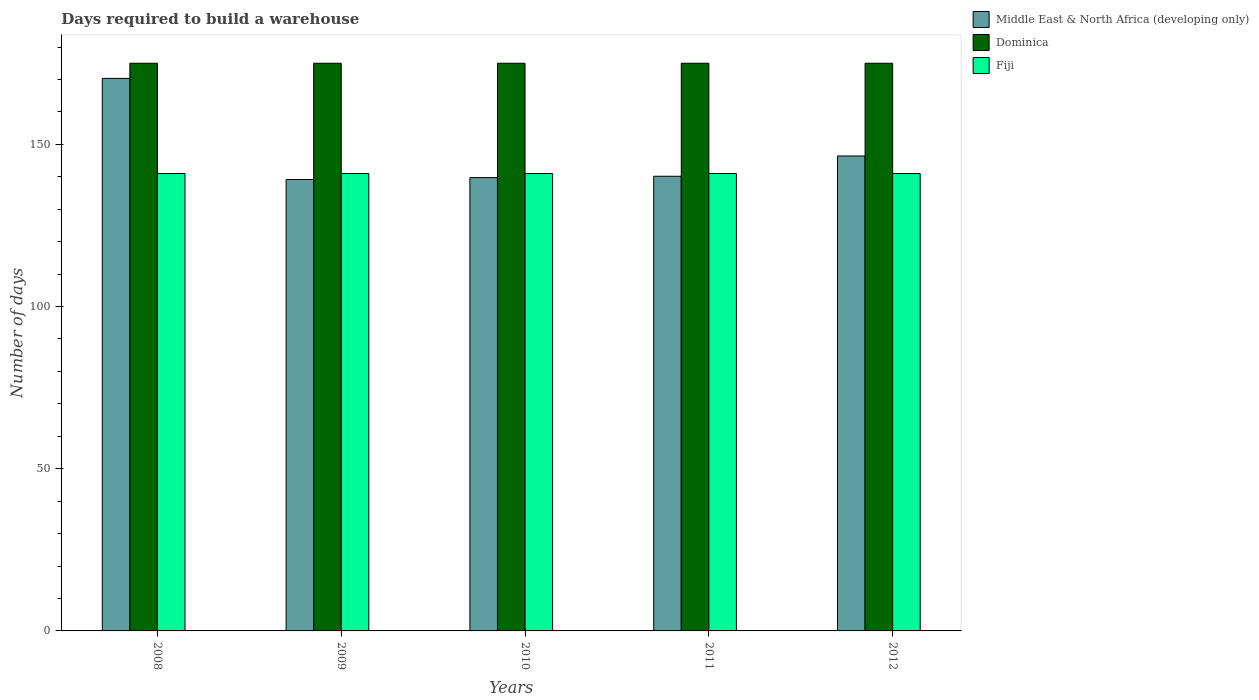How many different coloured bars are there?
Provide a short and direct response. 3. How many groups of bars are there?
Your response must be concise. 5. Are the number of bars per tick equal to the number of legend labels?
Provide a succinct answer. Yes. What is the days required to build a warehouse in in Dominica in 2011?
Give a very brief answer. 175. Across all years, what is the maximum days required to build a warehouse in in Middle East & North Africa (developing only)?
Your answer should be very brief. 170.33. Across all years, what is the minimum days required to build a warehouse in in Middle East & North Africa (developing only)?
Give a very brief answer. 139.17. What is the total days required to build a warehouse in in Fiji in the graph?
Keep it short and to the point. 705. What is the difference between the days required to build a warehouse in in Dominica in 2011 and that in 2012?
Keep it short and to the point. 0. What is the difference between the days required to build a warehouse in in Middle East & North Africa (developing only) in 2010 and the days required to build a warehouse in in Dominica in 2009?
Your response must be concise. -35.25. What is the average days required to build a warehouse in in Middle East & North Africa (developing only) per year?
Provide a short and direct response. 147.17. In the year 2009, what is the difference between the days required to build a warehouse in in Middle East & North Africa (developing only) and days required to build a warehouse in in Fiji?
Ensure brevity in your answer.  -1.83. In how many years, is the days required to build a warehouse in in Dominica greater than 140 days?
Your answer should be very brief. 5. Is the days required to build a warehouse in in Dominica in 2008 less than that in 2010?
Offer a very short reply. No. What is the difference between the highest and the second highest days required to build a warehouse in in Dominica?
Give a very brief answer. 0. What is the difference between the highest and the lowest days required to build a warehouse in in Dominica?
Your response must be concise. 0. In how many years, is the days required to build a warehouse in in Middle East & North Africa (developing only) greater than the average days required to build a warehouse in in Middle East & North Africa (developing only) taken over all years?
Provide a succinct answer. 1. Is the sum of the days required to build a warehouse in in Middle East & North Africa (developing only) in 2010 and 2012 greater than the maximum days required to build a warehouse in in Dominica across all years?
Give a very brief answer. Yes. What does the 1st bar from the left in 2009 represents?
Your response must be concise. Middle East & North Africa (developing only). What does the 3rd bar from the right in 2009 represents?
Offer a terse response. Middle East & North Africa (developing only). Are all the bars in the graph horizontal?
Provide a succinct answer. No. How many years are there in the graph?
Your answer should be very brief. 5. Does the graph contain any zero values?
Offer a very short reply. No. Does the graph contain grids?
Provide a succinct answer. No. Where does the legend appear in the graph?
Make the answer very short. Top right. How many legend labels are there?
Give a very brief answer. 3. What is the title of the graph?
Offer a very short reply. Days required to build a warehouse. Does "Belize" appear as one of the legend labels in the graph?
Provide a succinct answer. No. What is the label or title of the Y-axis?
Provide a succinct answer. Number of days. What is the Number of days of Middle East & North Africa (developing only) in 2008?
Offer a very short reply. 170.33. What is the Number of days in Dominica in 2008?
Offer a very short reply. 175. What is the Number of days in Fiji in 2008?
Offer a terse response. 141. What is the Number of days in Middle East & North Africa (developing only) in 2009?
Keep it short and to the point. 139.17. What is the Number of days of Dominica in 2009?
Keep it short and to the point. 175. What is the Number of days of Fiji in 2009?
Make the answer very short. 141. What is the Number of days of Middle East & North Africa (developing only) in 2010?
Your response must be concise. 139.75. What is the Number of days of Dominica in 2010?
Offer a very short reply. 175. What is the Number of days in Fiji in 2010?
Provide a succinct answer. 141. What is the Number of days in Middle East & North Africa (developing only) in 2011?
Keep it short and to the point. 140.17. What is the Number of days in Dominica in 2011?
Give a very brief answer. 175. What is the Number of days in Fiji in 2011?
Keep it short and to the point. 141. What is the Number of days in Middle East & North Africa (developing only) in 2012?
Your answer should be very brief. 146.42. What is the Number of days of Dominica in 2012?
Ensure brevity in your answer.  175. What is the Number of days in Fiji in 2012?
Your answer should be compact. 141. Across all years, what is the maximum Number of days of Middle East & North Africa (developing only)?
Keep it short and to the point. 170.33. Across all years, what is the maximum Number of days of Dominica?
Your response must be concise. 175. Across all years, what is the maximum Number of days of Fiji?
Offer a very short reply. 141. Across all years, what is the minimum Number of days of Middle East & North Africa (developing only)?
Make the answer very short. 139.17. Across all years, what is the minimum Number of days of Dominica?
Offer a terse response. 175. Across all years, what is the minimum Number of days in Fiji?
Your answer should be compact. 141. What is the total Number of days in Middle East & North Africa (developing only) in the graph?
Your response must be concise. 735.83. What is the total Number of days in Dominica in the graph?
Give a very brief answer. 875. What is the total Number of days in Fiji in the graph?
Your answer should be compact. 705. What is the difference between the Number of days in Middle East & North Africa (developing only) in 2008 and that in 2009?
Keep it short and to the point. 31.17. What is the difference between the Number of days in Middle East & North Africa (developing only) in 2008 and that in 2010?
Provide a short and direct response. 30.58. What is the difference between the Number of days in Middle East & North Africa (developing only) in 2008 and that in 2011?
Provide a short and direct response. 30.17. What is the difference between the Number of days of Dominica in 2008 and that in 2011?
Give a very brief answer. 0. What is the difference between the Number of days in Fiji in 2008 and that in 2011?
Your response must be concise. 0. What is the difference between the Number of days of Middle East & North Africa (developing only) in 2008 and that in 2012?
Offer a very short reply. 23.92. What is the difference between the Number of days in Dominica in 2008 and that in 2012?
Ensure brevity in your answer.  0. What is the difference between the Number of days of Middle East & North Africa (developing only) in 2009 and that in 2010?
Offer a very short reply. -0.58. What is the difference between the Number of days in Dominica in 2009 and that in 2010?
Make the answer very short. 0. What is the difference between the Number of days in Fiji in 2009 and that in 2010?
Your answer should be very brief. 0. What is the difference between the Number of days of Fiji in 2009 and that in 2011?
Make the answer very short. 0. What is the difference between the Number of days of Middle East & North Africa (developing only) in 2009 and that in 2012?
Provide a succinct answer. -7.25. What is the difference between the Number of days in Fiji in 2009 and that in 2012?
Your answer should be compact. 0. What is the difference between the Number of days of Middle East & North Africa (developing only) in 2010 and that in 2011?
Keep it short and to the point. -0.42. What is the difference between the Number of days in Middle East & North Africa (developing only) in 2010 and that in 2012?
Provide a short and direct response. -6.67. What is the difference between the Number of days in Fiji in 2010 and that in 2012?
Your answer should be very brief. 0. What is the difference between the Number of days in Middle East & North Africa (developing only) in 2011 and that in 2012?
Give a very brief answer. -6.25. What is the difference between the Number of days in Dominica in 2011 and that in 2012?
Ensure brevity in your answer.  0. What is the difference between the Number of days in Middle East & North Africa (developing only) in 2008 and the Number of days in Dominica in 2009?
Give a very brief answer. -4.67. What is the difference between the Number of days in Middle East & North Africa (developing only) in 2008 and the Number of days in Fiji in 2009?
Give a very brief answer. 29.33. What is the difference between the Number of days in Dominica in 2008 and the Number of days in Fiji in 2009?
Provide a short and direct response. 34. What is the difference between the Number of days of Middle East & North Africa (developing only) in 2008 and the Number of days of Dominica in 2010?
Your answer should be compact. -4.67. What is the difference between the Number of days of Middle East & North Africa (developing only) in 2008 and the Number of days of Fiji in 2010?
Offer a terse response. 29.33. What is the difference between the Number of days in Dominica in 2008 and the Number of days in Fiji in 2010?
Offer a terse response. 34. What is the difference between the Number of days of Middle East & North Africa (developing only) in 2008 and the Number of days of Dominica in 2011?
Offer a terse response. -4.67. What is the difference between the Number of days of Middle East & North Africa (developing only) in 2008 and the Number of days of Fiji in 2011?
Make the answer very short. 29.33. What is the difference between the Number of days in Middle East & North Africa (developing only) in 2008 and the Number of days in Dominica in 2012?
Make the answer very short. -4.67. What is the difference between the Number of days in Middle East & North Africa (developing only) in 2008 and the Number of days in Fiji in 2012?
Your answer should be very brief. 29.33. What is the difference between the Number of days in Dominica in 2008 and the Number of days in Fiji in 2012?
Keep it short and to the point. 34. What is the difference between the Number of days in Middle East & North Africa (developing only) in 2009 and the Number of days in Dominica in 2010?
Ensure brevity in your answer.  -35.83. What is the difference between the Number of days of Middle East & North Africa (developing only) in 2009 and the Number of days of Fiji in 2010?
Your answer should be very brief. -1.83. What is the difference between the Number of days in Dominica in 2009 and the Number of days in Fiji in 2010?
Give a very brief answer. 34. What is the difference between the Number of days of Middle East & North Africa (developing only) in 2009 and the Number of days of Dominica in 2011?
Your answer should be compact. -35.83. What is the difference between the Number of days of Middle East & North Africa (developing only) in 2009 and the Number of days of Fiji in 2011?
Offer a terse response. -1.83. What is the difference between the Number of days of Middle East & North Africa (developing only) in 2009 and the Number of days of Dominica in 2012?
Offer a terse response. -35.83. What is the difference between the Number of days in Middle East & North Africa (developing only) in 2009 and the Number of days in Fiji in 2012?
Offer a terse response. -1.83. What is the difference between the Number of days in Middle East & North Africa (developing only) in 2010 and the Number of days in Dominica in 2011?
Keep it short and to the point. -35.25. What is the difference between the Number of days of Middle East & North Africa (developing only) in 2010 and the Number of days of Fiji in 2011?
Your response must be concise. -1.25. What is the difference between the Number of days of Dominica in 2010 and the Number of days of Fiji in 2011?
Provide a short and direct response. 34. What is the difference between the Number of days of Middle East & North Africa (developing only) in 2010 and the Number of days of Dominica in 2012?
Your answer should be very brief. -35.25. What is the difference between the Number of days in Middle East & North Africa (developing only) in 2010 and the Number of days in Fiji in 2012?
Offer a terse response. -1.25. What is the difference between the Number of days in Middle East & North Africa (developing only) in 2011 and the Number of days in Dominica in 2012?
Ensure brevity in your answer.  -34.83. What is the difference between the Number of days of Dominica in 2011 and the Number of days of Fiji in 2012?
Your response must be concise. 34. What is the average Number of days in Middle East & North Africa (developing only) per year?
Ensure brevity in your answer.  147.17. What is the average Number of days in Dominica per year?
Your answer should be very brief. 175. What is the average Number of days of Fiji per year?
Your answer should be very brief. 141. In the year 2008, what is the difference between the Number of days in Middle East & North Africa (developing only) and Number of days in Dominica?
Make the answer very short. -4.67. In the year 2008, what is the difference between the Number of days in Middle East & North Africa (developing only) and Number of days in Fiji?
Offer a terse response. 29.33. In the year 2008, what is the difference between the Number of days of Dominica and Number of days of Fiji?
Your response must be concise. 34. In the year 2009, what is the difference between the Number of days in Middle East & North Africa (developing only) and Number of days in Dominica?
Give a very brief answer. -35.83. In the year 2009, what is the difference between the Number of days of Middle East & North Africa (developing only) and Number of days of Fiji?
Offer a terse response. -1.83. In the year 2010, what is the difference between the Number of days in Middle East & North Africa (developing only) and Number of days in Dominica?
Your answer should be very brief. -35.25. In the year 2010, what is the difference between the Number of days of Middle East & North Africa (developing only) and Number of days of Fiji?
Ensure brevity in your answer.  -1.25. In the year 2010, what is the difference between the Number of days of Dominica and Number of days of Fiji?
Your answer should be compact. 34. In the year 2011, what is the difference between the Number of days of Middle East & North Africa (developing only) and Number of days of Dominica?
Offer a very short reply. -34.83. In the year 2012, what is the difference between the Number of days in Middle East & North Africa (developing only) and Number of days in Dominica?
Your answer should be compact. -28.58. In the year 2012, what is the difference between the Number of days in Middle East & North Africa (developing only) and Number of days in Fiji?
Your response must be concise. 5.42. In the year 2012, what is the difference between the Number of days of Dominica and Number of days of Fiji?
Make the answer very short. 34. What is the ratio of the Number of days of Middle East & North Africa (developing only) in 2008 to that in 2009?
Your answer should be compact. 1.22. What is the ratio of the Number of days in Middle East & North Africa (developing only) in 2008 to that in 2010?
Provide a succinct answer. 1.22. What is the ratio of the Number of days in Dominica in 2008 to that in 2010?
Offer a terse response. 1. What is the ratio of the Number of days of Fiji in 2008 to that in 2010?
Provide a succinct answer. 1. What is the ratio of the Number of days of Middle East & North Africa (developing only) in 2008 to that in 2011?
Provide a succinct answer. 1.22. What is the ratio of the Number of days in Fiji in 2008 to that in 2011?
Ensure brevity in your answer.  1. What is the ratio of the Number of days of Middle East & North Africa (developing only) in 2008 to that in 2012?
Give a very brief answer. 1.16. What is the ratio of the Number of days in Middle East & North Africa (developing only) in 2009 to that in 2010?
Your answer should be compact. 1. What is the ratio of the Number of days of Middle East & North Africa (developing only) in 2009 to that in 2012?
Offer a terse response. 0.95. What is the ratio of the Number of days in Dominica in 2009 to that in 2012?
Ensure brevity in your answer.  1. What is the ratio of the Number of days of Dominica in 2010 to that in 2011?
Provide a succinct answer. 1. What is the ratio of the Number of days of Fiji in 2010 to that in 2011?
Provide a succinct answer. 1. What is the ratio of the Number of days in Middle East & North Africa (developing only) in 2010 to that in 2012?
Offer a very short reply. 0.95. What is the ratio of the Number of days of Middle East & North Africa (developing only) in 2011 to that in 2012?
Provide a succinct answer. 0.96. What is the ratio of the Number of days of Dominica in 2011 to that in 2012?
Your answer should be compact. 1. What is the ratio of the Number of days of Fiji in 2011 to that in 2012?
Ensure brevity in your answer.  1. What is the difference between the highest and the second highest Number of days in Middle East & North Africa (developing only)?
Give a very brief answer. 23.92. What is the difference between the highest and the lowest Number of days in Middle East & North Africa (developing only)?
Give a very brief answer. 31.17. What is the difference between the highest and the lowest Number of days of Fiji?
Your response must be concise. 0. 